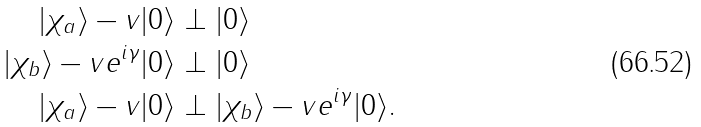<formula> <loc_0><loc_0><loc_500><loc_500>| \chi _ { a } \rangle - v | 0 \rangle & \perp | 0 \rangle \\ | \chi _ { b } \rangle - v e ^ { i \gamma } | 0 \rangle & \perp | 0 \rangle \\ | \chi _ { a } \rangle - v | 0 \rangle & \perp | \chi _ { b } \rangle - v e ^ { i \gamma } | 0 \rangle .</formula> 